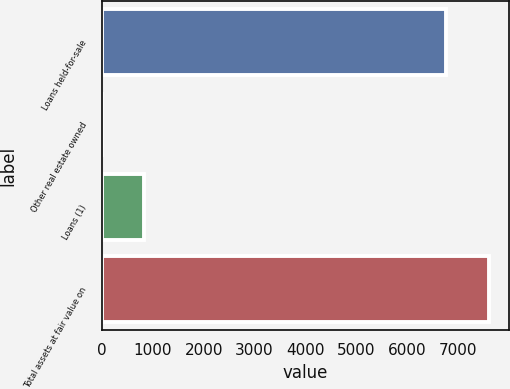Convert chart to OTSL. <chart><loc_0><loc_0><loc_500><loc_500><bar_chart><fcel>Loans held-for-sale<fcel>Other real estate owned<fcel>Loans (1)<fcel>Total assets at fair value on<nl><fcel>6752<fcel>15<fcel>836<fcel>7603<nl></chart> 